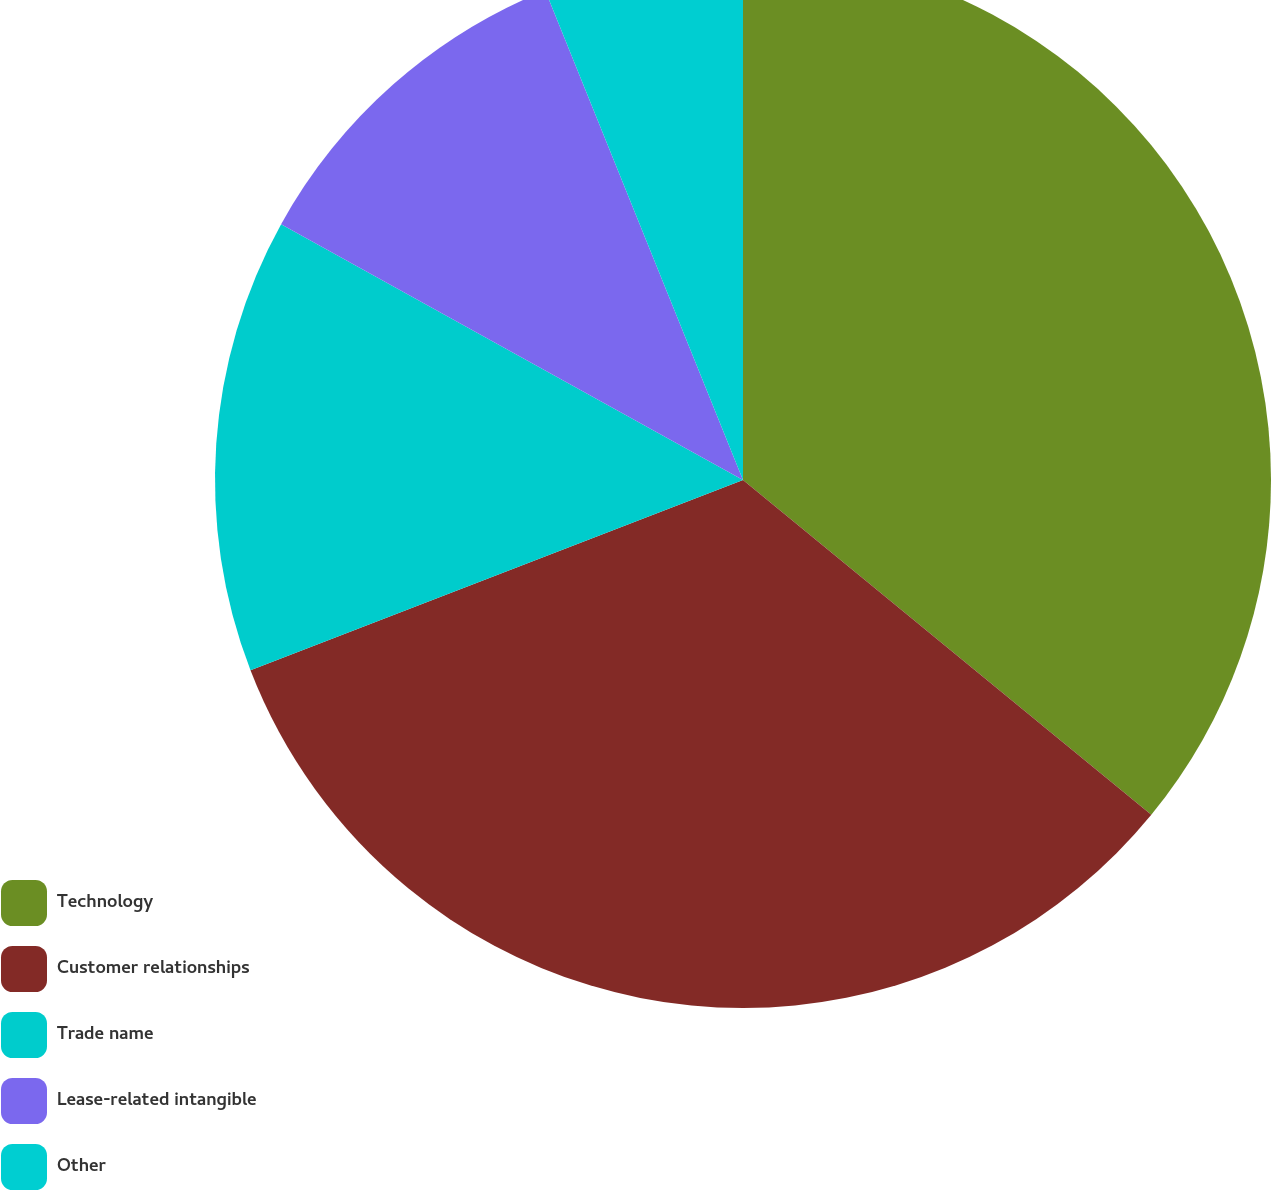<chart> <loc_0><loc_0><loc_500><loc_500><pie_chart><fcel>Technology<fcel>Customer relationships<fcel>Trade name<fcel>Lease-related intangible<fcel>Other<nl><fcel>35.93%<fcel>33.2%<fcel>13.92%<fcel>10.84%<fcel>6.11%<nl></chart> 